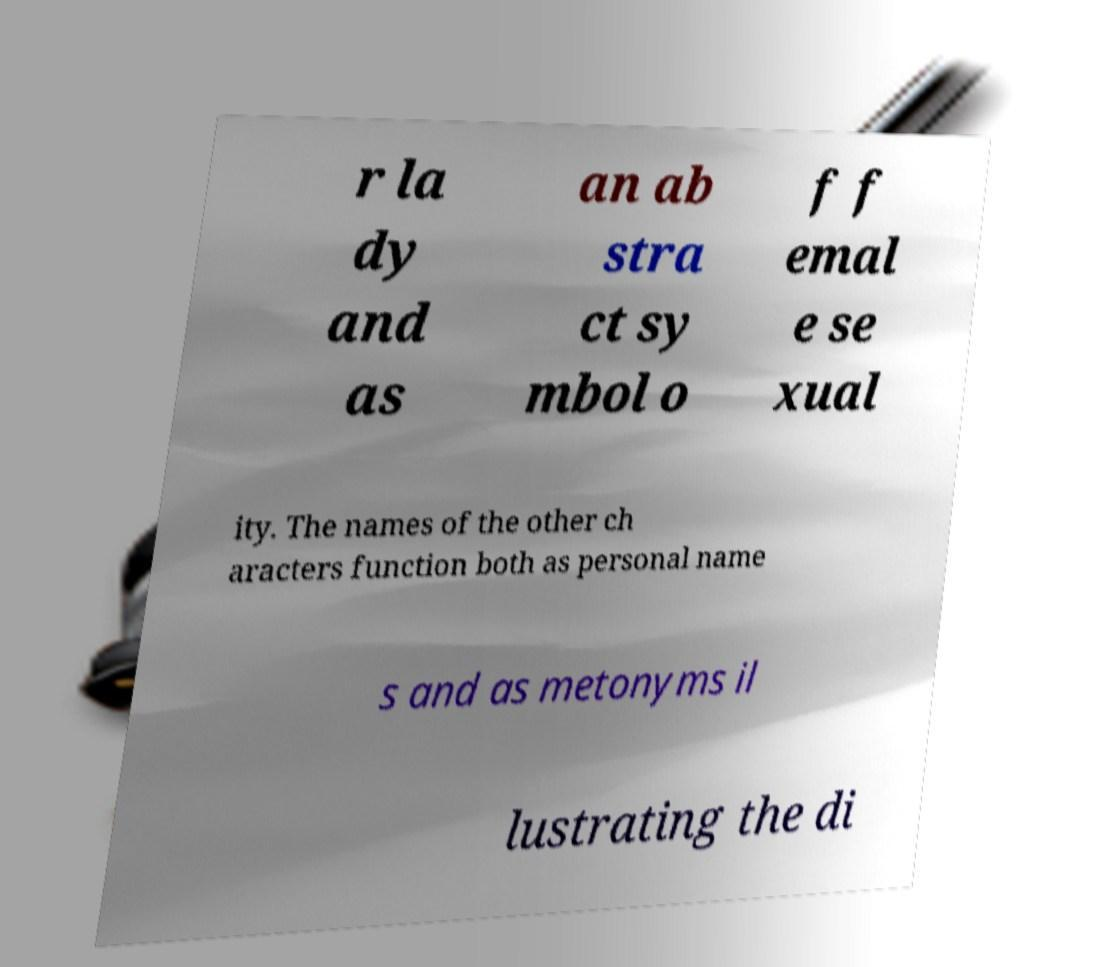For documentation purposes, I need the text within this image transcribed. Could you provide that? r la dy and as an ab stra ct sy mbol o f f emal e se xual ity. The names of the other ch aracters function both as personal name s and as metonyms il lustrating the di 